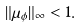Convert formula to latex. <formula><loc_0><loc_0><loc_500><loc_500>\| \mu _ { \phi } \| _ { \infty } < 1 .</formula> 